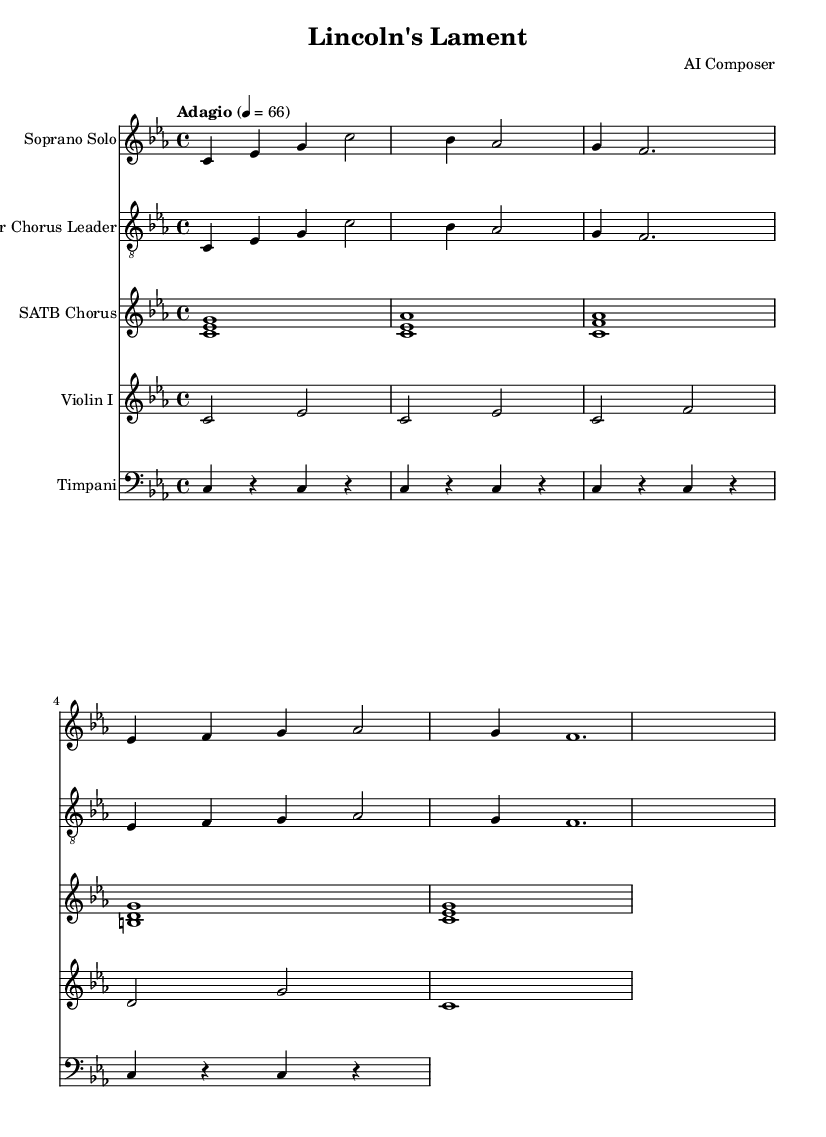What is the key signature of this music? The key signature shown at the beginning of the sheet music is C minor, which has three flats.
Answer: C minor What is the time signature of this music? The time signature is indicated at the beginning as 4/4, meaning there are four beats in each measure, and the quarter note gets one beat.
Answer: 4/4 What is the tempo marking of this piece? The tempo marking is "Adagio," which indicates a slow tempo, and is specified to be at 66 beats per minute.
Answer: Adagio How many measures does the soprano solo cover? By counting the measures in the soprano solo staff, there are four measures total.
Answer: Four What is the dynamic marking for the chorus section? The score does not include specific dynamic markings, indicating that it may be left to the performers' interpretation, therefore, the answer is none.
Answer: None Which instrument has the highest pitch range in this piece? In the context of the instruments listed, the soprano solo typically has the highest pitch range compared to the tenor chorus leader and the SATB chorus.
Answer: Soprano Solo What thematic element is expressed in the soprano solo lyrics? The lyrics of the soprano solo express themes of unity and the consequences of division in a torn nation, as suggested by phrases like "nation torn" and "united we must stand as one."
Answer: Unity 